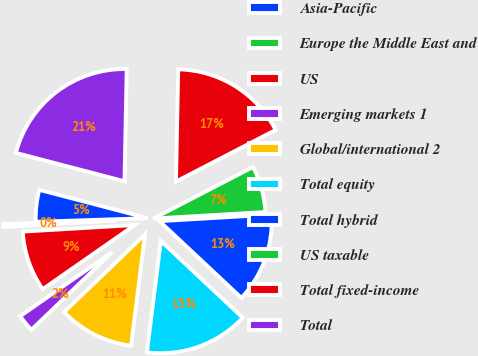Convert chart. <chart><loc_0><loc_0><loc_500><loc_500><pie_chart><fcel>Asia-Pacific<fcel>Europe the Middle East and<fcel>US<fcel>Emerging markets 1<fcel>Global/international 2<fcel>Total equity<fcel>Total hybrid<fcel>US taxable<fcel>Total fixed-income<fcel>Total<nl><fcel>4.58%<fcel>0.42%<fcel>8.75%<fcel>2.5%<fcel>10.83%<fcel>15.0%<fcel>12.92%<fcel>6.67%<fcel>17.08%<fcel>21.25%<nl></chart> 